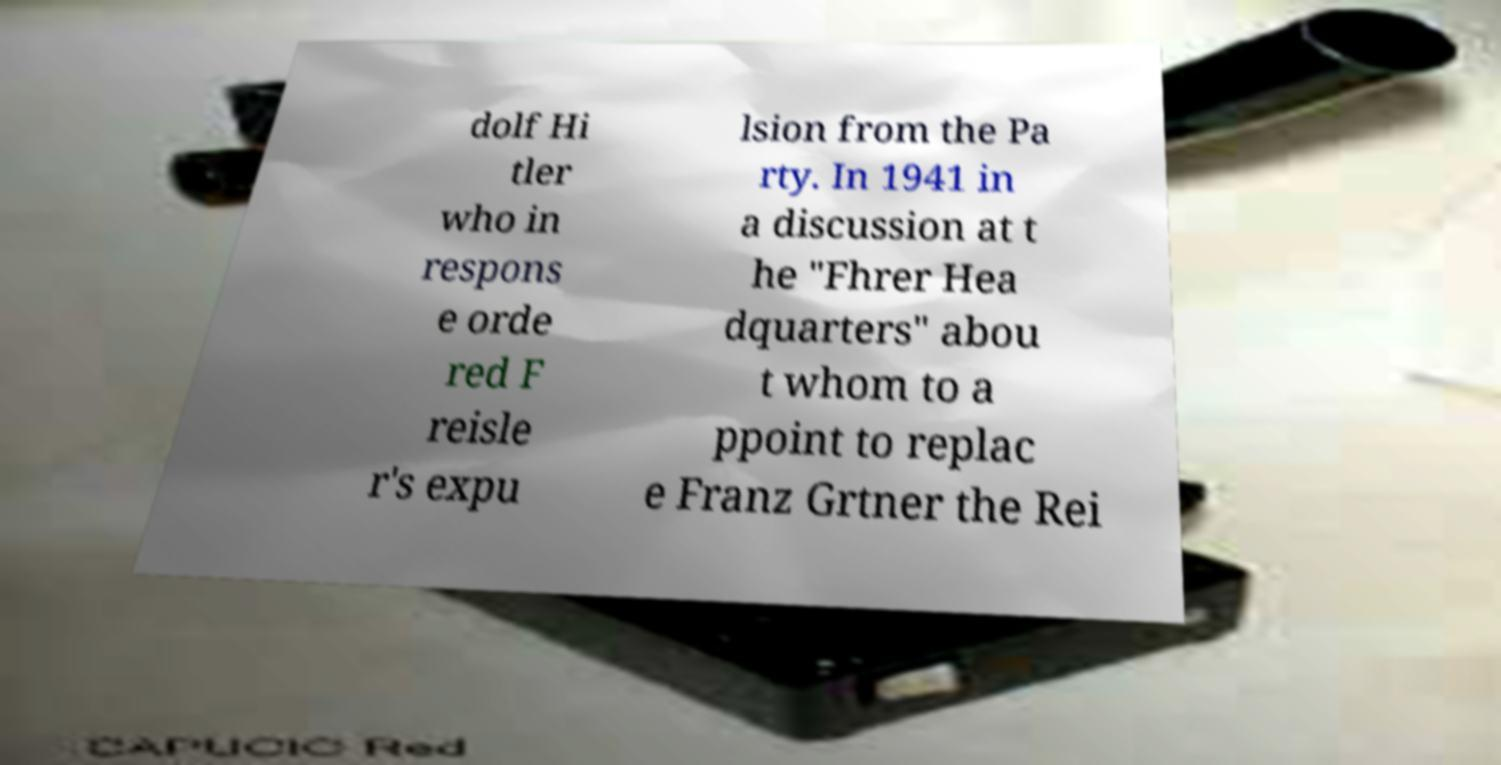I need the written content from this picture converted into text. Can you do that? dolf Hi tler who in respons e orde red F reisle r's expu lsion from the Pa rty. In 1941 in a discussion at t he "Fhrer Hea dquarters" abou t whom to a ppoint to replac e Franz Grtner the Rei 